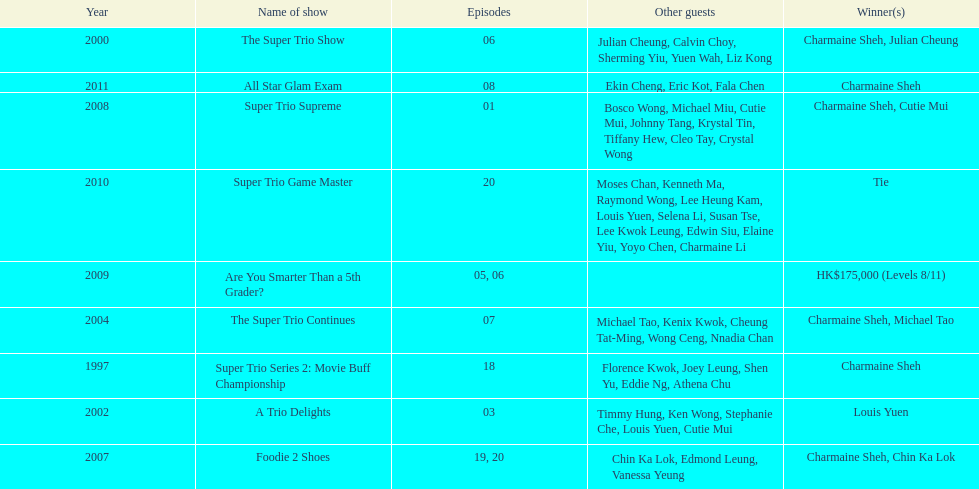Before appearing on another variety show, how many continuous trio shows did charmaine sheh perform in? 34. 